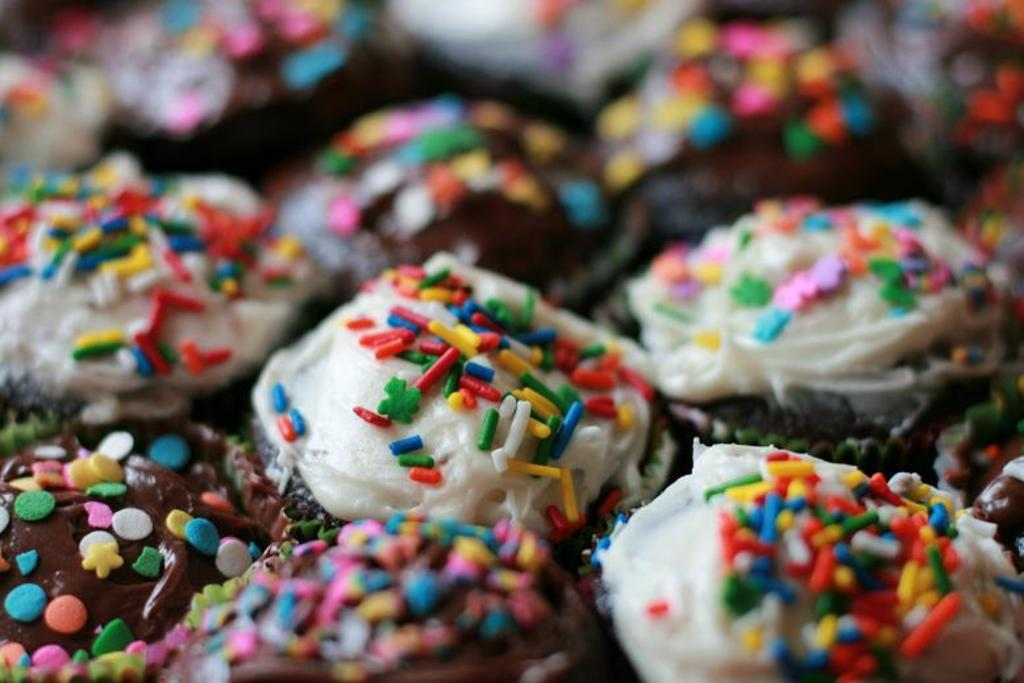What type of food is featured in the image? There are many cupcakes in the image. What is on top of the cupcakes? The cupcakes have cream and sprinkles on them. What type of prison can be seen in the background of the image? There is no prison present in the image; it features cupcakes with cream and sprinkles. 